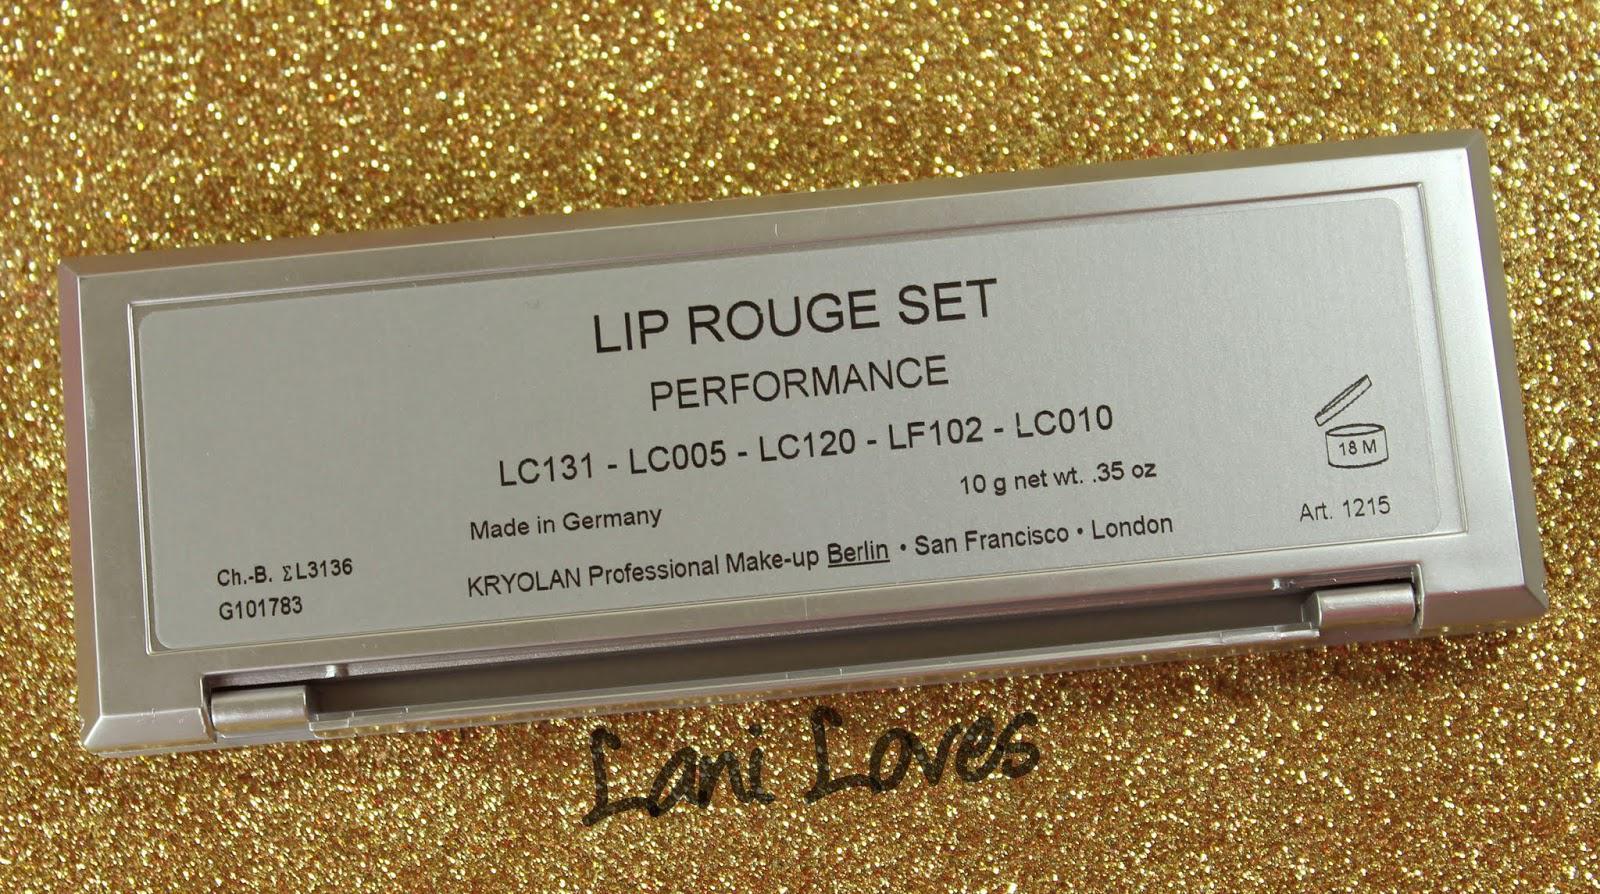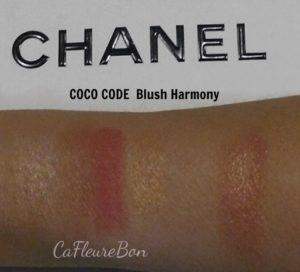The first image is the image on the left, the second image is the image on the right. For the images shown, is this caption "Each image shows lipstick marks on skin displayed in a horizontal row." true? Answer yes or no. No. The first image is the image on the left, the second image is the image on the right. Analyze the images presented: Is the assertion "The person in the left image has lighter skin than the person in the right image." valid? Answer yes or no. No. 